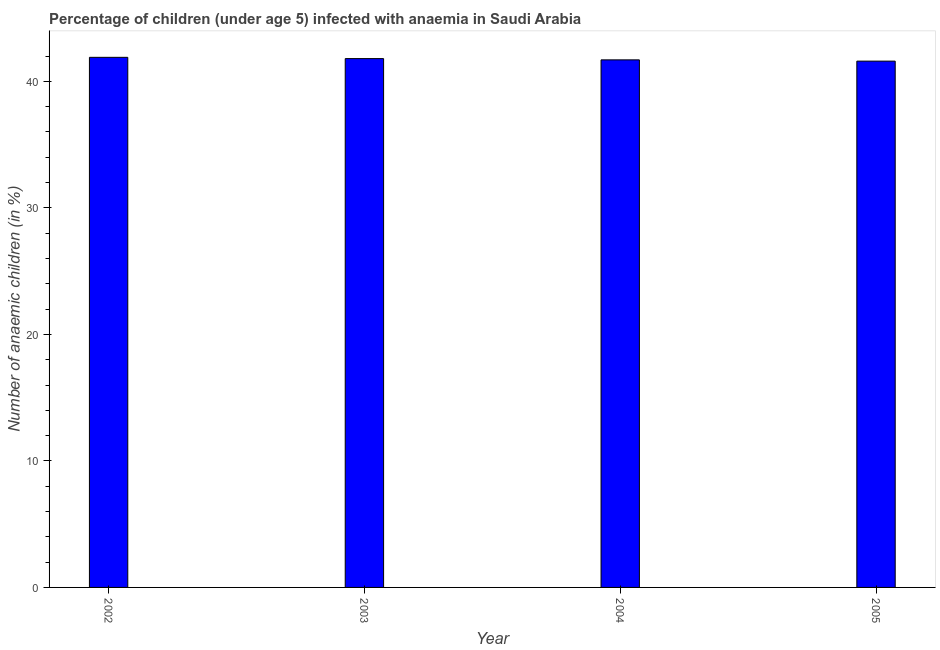Does the graph contain any zero values?
Provide a short and direct response. No. What is the title of the graph?
Offer a terse response. Percentage of children (under age 5) infected with anaemia in Saudi Arabia. What is the label or title of the Y-axis?
Offer a very short reply. Number of anaemic children (in %). What is the number of anaemic children in 2005?
Keep it short and to the point. 41.6. Across all years, what is the maximum number of anaemic children?
Make the answer very short. 41.9. Across all years, what is the minimum number of anaemic children?
Provide a succinct answer. 41.6. In which year was the number of anaemic children maximum?
Give a very brief answer. 2002. What is the sum of the number of anaemic children?
Your answer should be compact. 167. What is the difference between the number of anaemic children in 2002 and 2004?
Keep it short and to the point. 0.2. What is the average number of anaemic children per year?
Provide a short and direct response. 41.75. What is the median number of anaemic children?
Keep it short and to the point. 41.75. Do a majority of the years between 2003 and 2005 (inclusive) have number of anaemic children greater than 30 %?
Your answer should be very brief. Yes. Is the difference between the number of anaemic children in 2004 and 2005 greater than the difference between any two years?
Make the answer very short. No. Is the sum of the number of anaemic children in 2002 and 2003 greater than the maximum number of anaemic children across all years?
Your response must be concise. Yes. What is the difference between the highest and the lowest number of anaemic children?
Your answer should be very brief. 0.3. How many bars are there?
Make the answer very short. 4. What is the difference between two consecutive major ticks on the Y-axis?
Your answer should be very brief. 10. Are the values on the major ticks of Y-axis written in scientific E-notation?
Keep it short and to the point. No. What is the Number of anaemic children (in %) of 2002?
Your response must be concise. 41.9. What is the Number of anaemic children (in %) in 2003?
Provide a succinct answer. 41.8. What is the Number of anaemic children (in %) in 2004?
Give a very brief answer. 41.7. What is the Number of anaemic children (in %) in 2005?
Give a very brief answer. 41.6. What is the difference between the Number of anaemic children (in %) in 2002 and 2004?
Provide a succinct answer. 0.2. What is the difference between the Number of anaemic children (in %) in 2002 and 2005?
Provide a succinct answer. 0.3. What is the difference between the Number of anaemic children (in %) in 2003 and 2004?
Your answer should be compact. 0.1. What is the difference between the Number of anaemic children (in %) in 2003 and 2005?
Provide a succinct answer. 0.2. What is the ratio of the Number of anaemic children (in %) in 2002 to that in 2004?
Provide a succinct answer. 1. What is the ratio of the Number of anaemic children (in %) in 2002 to that in 2005?
Make the answer very short. 1.01. What is the ratio of the Number of anaemic children (in %) in 2003 to that in 2005?
Offer a terse response. 1. 